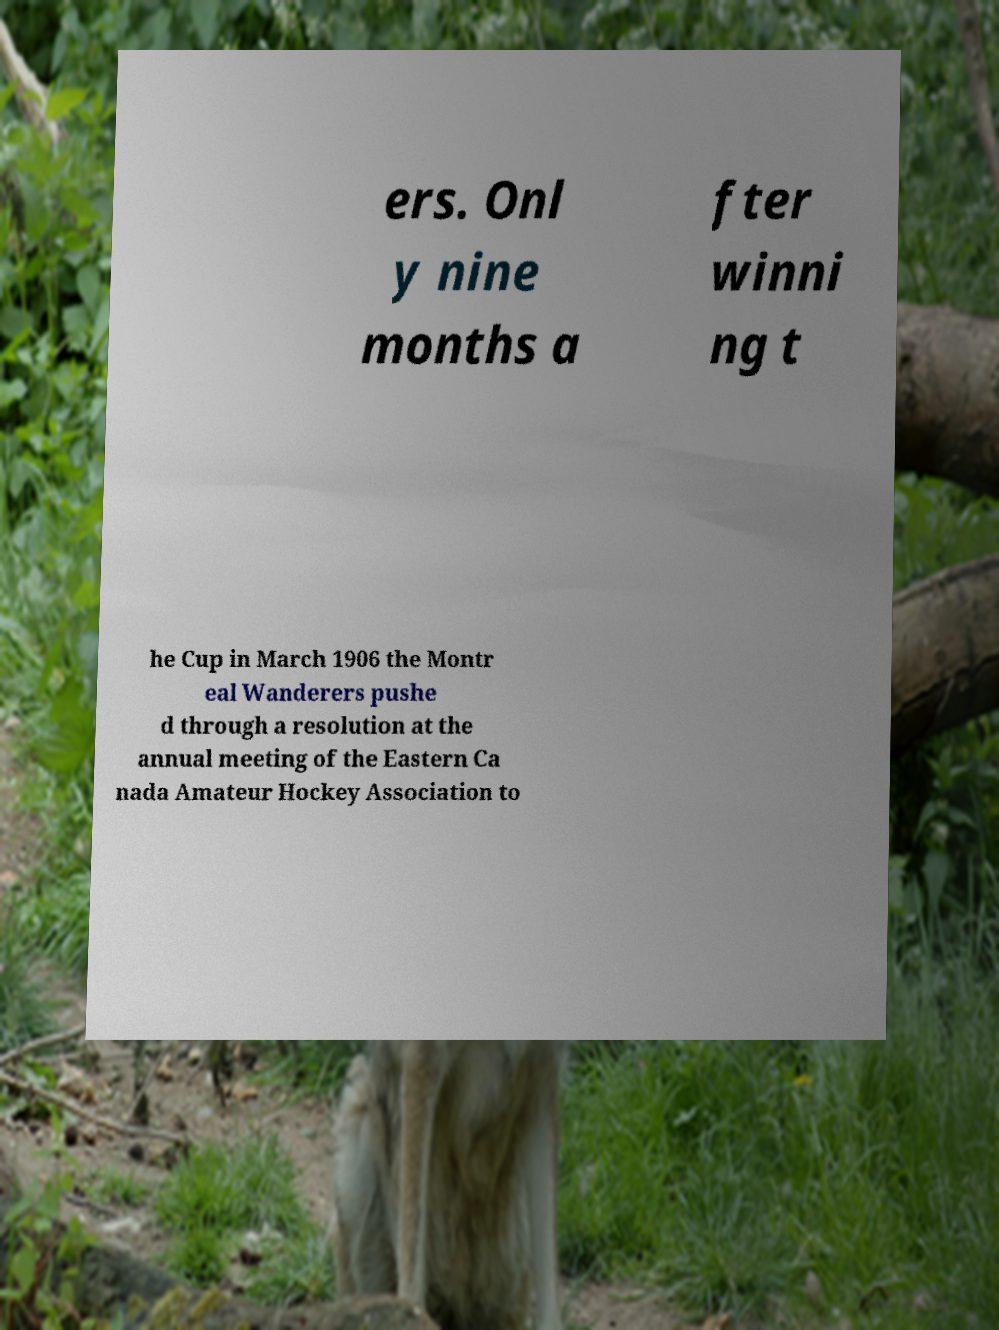Can you accurately transcribe the text from the provided image for me? ers. Onl y nine months a fter winni ng t he Cup in March 1906 the Montr eal Wanderers pushe d through a resolution at the annual meeting of the Eastern Ca nada Amateur Hockey Association to 